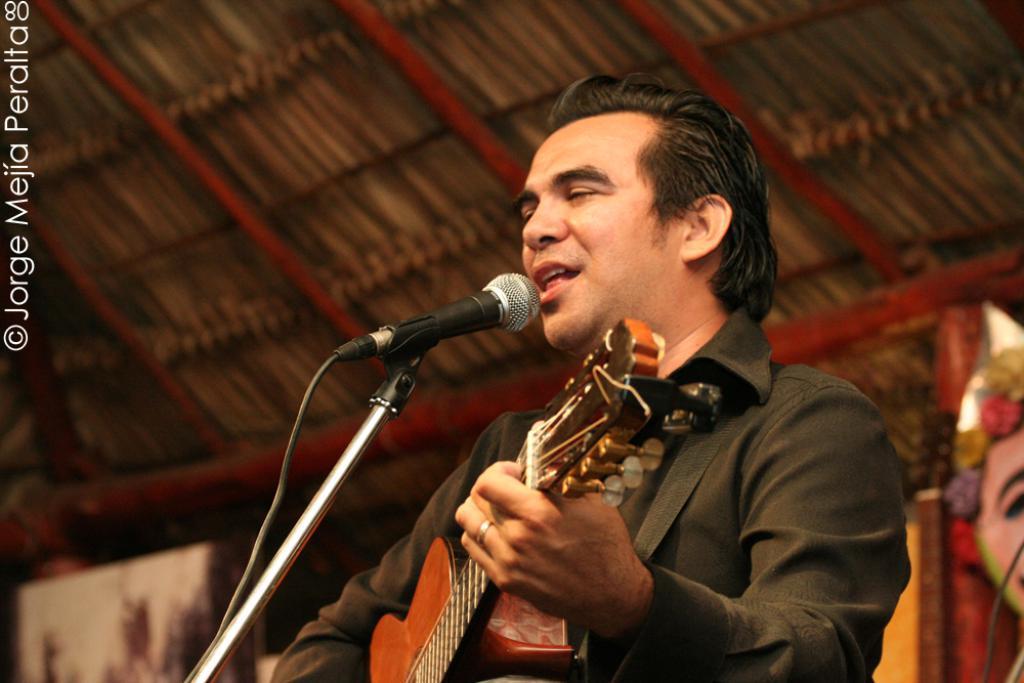Could you give a brief overview of what you see in this image? He is holding a guitar. He is singing a song. He is wearing a black color jacket. We can see in background tent and poster. 